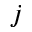Convert formula to latex. <formula><loc_0><loc_0><loc_500><loc_500>j</formula> 